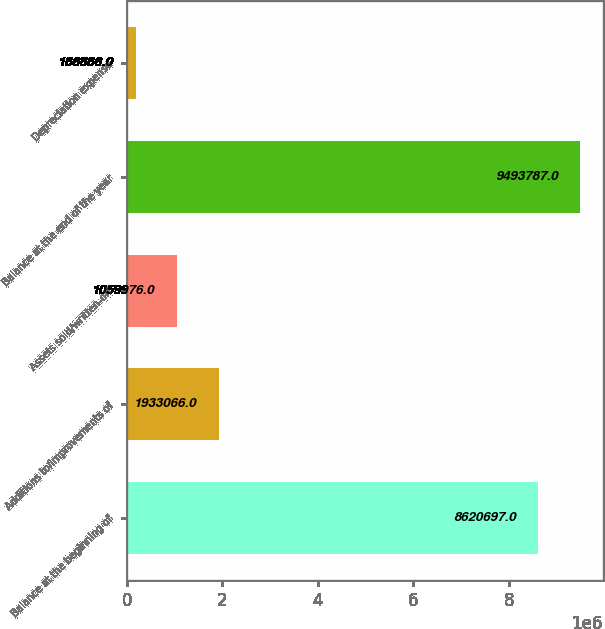<chart> <loc_0><loc_0><loc_500><loc_500><bar_chart><fcel>Balance at the beginning of<fcel>Additions to/improvements of<fcel>Assets sold/written-off<fcel>Balance at the end of the year<fcel>Depreciation expense<nl><fcel>8.6207e+06<fcel>1.93307e+06<fcel>1.05998e+06<fcel>9.49379e+06<fcel>186886<nl></chart> 